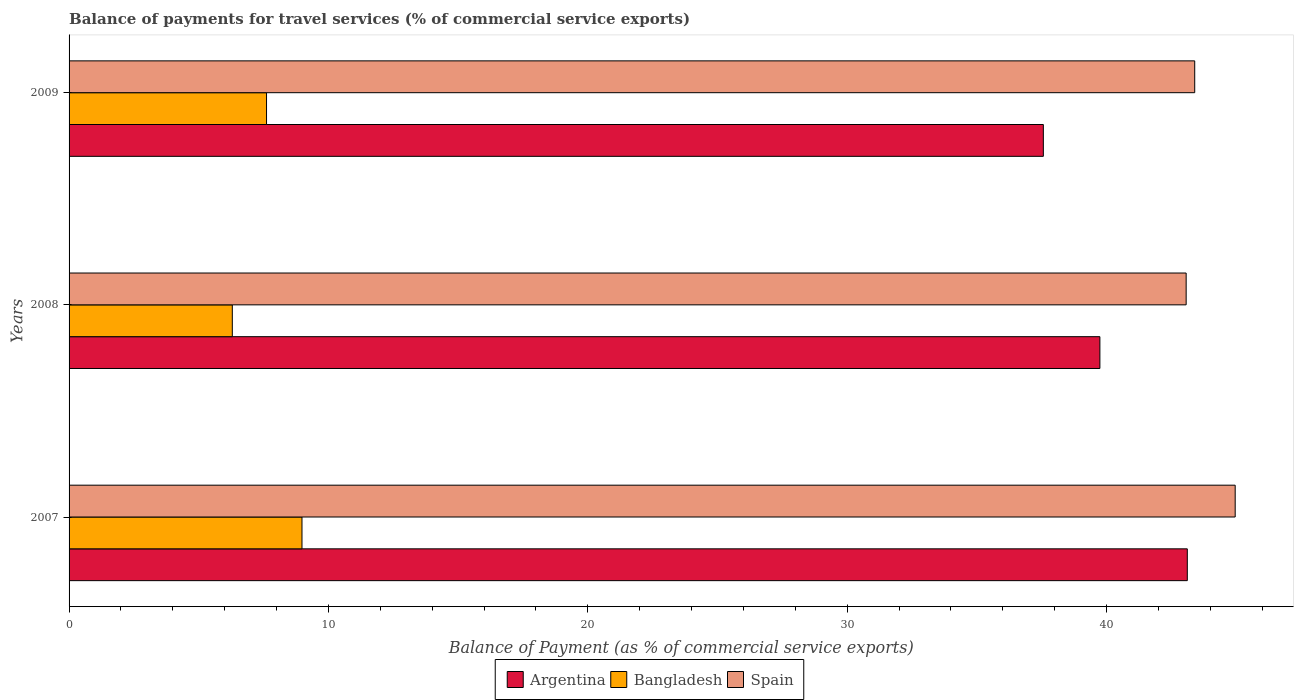How many groups of bars are there?
Give a very brief answer. 3. Are the number of bars on each tick of the Y-axis equal?
Provide a short and direct response. Yes. How many bars are there on the 1st tick from the bottom?
Offer a terse response. 3. What is the label of the 1st group of bars from the top?
Provide a succinct answer. 2009. In how many cases, is the number of bars for a given year not equal to the number of legend labels?
Provide a short and direct response. 0. What is the balance of payments for travel services in Bangladesh in 2009?
Provide a short and direct response. 7.61. Across all years, what is the maximum balance of payments for travel services in Spain?
Offer a terse response. 44.96. Across all years, what is the minimum balance of payments for travel services in Bangladesh?
Your answer should be very brief. 6.29. In which year was the balance of payments for travel services in Argentina maximum?
Your answer should be compact. 2007. In which year was the balance of payments for travel services in Spain minimum?
Your answer should be compact. 2008. What is the total balance of payments for travel services in Bangladesh in the graph?
Provide a succinct answer. 22.89. What is the difference between the balance of payments for travel services in Spain in 2008 and that in 2009?
Give a very brief answer. -0.33. What is the difference between the balance of payments for travel services in Argentina in 2009 and the balance of payments for travel services in Spain in 2007?
Make the answer very short. -7.4. What is the average balance of payments for travel services in Spain per year?
Offer a very short reply. 43.81. In the year 2008, what is the difference between the balance of payments for travel services in Spain and balance of payments for travel services in Bangladesh?
Keep it short and to the point. 36.77. In how many years, is the balance of payments for travel services in Spain greater than 2 %?
Make the answer very short. 3. What is the ratio of the balance of payments for travel services in Argentina in 2008 to that in 2009?
Provide a succinct answer. 1.06. What is the difference between the highest and the second highest balance of payments for travel services in Spain?
Your answer should be compact. 1.56. What is the difference between the highest and the lowest balance of payments for travel services in Spain?
Your response must be concise. 1.89. Is the sum of the balance of payments for travel services in Bangladesh in 2008 and 2009 greater than the maximum balance of payments for travel services in Argentina across all years?
Provide a succinct answer. No. What does the 3rd bar from the top in 2007 represents?
Ensure brevity in your answer.  Argentina. How many years are there in the graph?
Provide a succinct answer. 3. What is the difference between two consecutive major ticks on the X-axis?
Make the answer very short. 10. Does the graph contain any zero values?
Give a very brief answer. No. How are the legend labels stacked?
Your answer should be compact. Horizontal. What is the title of the graph?
Provide a succinct answer. Balance of payments for travel services (% of commercial service exports). Does "Russian Federation" appear as one of the legend labels in the graph?
Your response must be concise. No. What is the label or title of the X-axis?
Your answer should be very brief. Balance of Payment (as % of commercial service exports). What is the Balance of Payment (as % of commercial service exports) of Argentina in 2007?
Give a very brief answer. 43.11. What is the Balance of Payment (as % of commercial service exports) of Bangladesh in 2007?
Your response must be concise. 8.98. What is the Balance of Payment (as % of commercial service exports) of Spain in 2007?
Provide a succinct answer. 44.96. What is the Balance of Payment (as % of commercial service exports) in Argentina in 2008?
Make the answer very short. 39.74. What is the Balance of Payment (as % of commercial service exports) in Bangladesh in 2008?
Give a very brief answer. 6.29. What is the Balance of Payment (as % of commercial service exports) of Spain in 2008?
Provide a short and direct response. 43.07. What is the Balance of Payment (as % of commercial service exports) in Argentina in 2009?
Ensure brevity in your answer.  37.56. What is the Balance of Payment (as % of commercial service exports) of Bangladesh in 2009?
Give a very brief answer. 7.61. What is the Balance of Payment (as % of commercial service exports) in Spain in 2009?
Provide a short and direct response. 43.4. Across all years, what is the maximum Balance of Payment (as % of commercial service exports) in Argentina?
Give a very brief answer. 43.11. Across all years, what is the maximum Balance of Payment (as % of commercial service exports) in Bangladesh?
Offer a terse response. 8.98. Across all years, what is the maximum Balance of Payment (as % of commercial service exports) of Spain?
Make the answer very short. 44.96. Across all years, what is the minimum Balance of Payment (as % of commercial service exports) of Argentina?
Make the answer very short. 37.56. Across all years, what is the minimum Balance of Payment (as % of commercial service exports) in Bangladesh?
Give a very brief answer. 6.29. Across all years, what is the minimum Balance of Payment (as % of commercial service exports) of Spain?
Provide a short and direct response. 43.07. What is the total Balance of Payment (as % of commercial service exports) in Argentina in the graph?
Keep it short and to the point. 120.42. What is the total Balance of Payment (as % of commercial service exports) of Bangladesh in the graph?
Your answer should be very brief. 22.89. What is the total Balance of Payment (as % of commercial service exports) of Spain in the graph?
Offer a very short reply. 131.42. What is the difference between the Balance of Payment (as % of commercial service exports) of Argentina in 2007 and that in 2008?
Provide a short and direct response. 3.37. What is the difference between the Balance of Payment (as % of commercial service exports) in Bangladesh in 2007 and that in 2008?
Ensure brevity in your answer.  2.69. What is the difference between the Balance of Payment (as % of commercial service exports) in Spain in 2007 and that in 2008?
Your answer should be very brief. 1.89. What is the difference between the Balance of Payment (as % of commercial service exports) in Argentina in 2007 and that in 2009?
Offer a terse response. 5.55. What is the difference between the Balance of Payment (as % of commercial service exports) of Bangladesh in 2007 and that in 2009?
Offer a terse response. 1.37. What is the difference between the Balance of Payment (as % of commercial service exports) of Spain in 2007 and that in 2009?
Give a very brief answer. 1.56. What is the difference between the Balance of Payment (as % of commercial service exports) in Argentina in 2008 and that in 2009?
Give a very brief answer. 2.18. What is the difference between the Balance of Payment (as % of commercial service exports) of Bangladesh in 2008 and that in 2009?
Offer a terse response. -1.32. What is the difference between the Balance of Payment (as % of commercial service exports) of Spain in 2008 and that in 2009?
Give a very brief answer. -0.33. What is the difference between the Balance of Payment (as % of commercial service exports) of Argentina in 2007 and the Balance of Payment (as % of commercial service exports) of Bangladesh in 2008?
Give a very brief answer. 36.82. What is the difference between the Balance of Payment (as % of commercial service exports) of Argentina in 2007 and the Balance of Payment (as % of commercial service exports) of Spain in 2008?
Your answer should be compact. 0.04. What is the difference between the Balance of Payment (as % of commercial service exports) in Bangladesh in 2007 and the Balance of Payment (as % of commercial service exports) in Spain in 2008?
Ensure brevity in your answer.  -34.09. What is the difference between the Balance of Payment (as % of commercial service exports) of Argentina in 2007 and the Balance of Payment (as % of commercial service exports) of Bangladesh in 2009?
Ensure brevity in your answer.  35.5. What is the difference between the Balance of Payment (as % of commercial service exports) in Argentina in 2007 and the Balance of Payment (as % of commercial service exports) in Spain in 2009?
Provide a short and direct response. -0.29. What is the difference between the Balance of Payment (as % of commercial service exports) in Bangladesh in 2007 and the Balance of Payment (as % of commercial service exports) in Spain in 2009?
Your response must be concise. -34.42. What is the difference between the Balance of Payment (as % of commercial service exports) in Argentina in 2008 and the Balance of Payment (as % of commercial service exports) in Bangladesh in 2009?
Offer a very short reply. 32.13. What is the difference between the Balance of Payment (as % of commercial service exports) in Argentina in 2008 and the Balance of Payment (as % of commercial service exports) in Spain in 2009?
Offer a very short reply. -3.66. What is the difference between the Balance of Payment (as % of commercial service exports) in Bangladesh in 2008 and the Balance of Payment (as % of commercial service exports) in Spain in 2009?
Provide a succinct answer. -37.1. What is the average Balance of Payment (as % of commercial service exports) in Argentina per year?
Offer a very short reply. 40.14. What is the average Balance of Payment (as % of commercial service exports) in Bangladesh per year?
Your answer should be compact. 7.63. What is the average Balance of Payment (as % of commercial service exports) in Spain per year?
Provide a succinct answer. 43.81. In the year 2007, what is the difference between the Balance of Payment (as % of commercial service exports) of Argentina and Balance of Payment (as % of commercial service exports) of Bangladesh?
Give a very brief answer. 34.13. In the year 2007, what is the difference between the Balance of Payment (as % of commercial service exports) in Argentina and Balance of Payment (as % of commercial service exports) in Spain?
Provide a succinct answer. -1.85. In the year 2007, what is the difference between the Balance of Payment (as % of commercial service exports) of Bangladesh and Balance of Payment (as % of commercial service exports) of Spain?
Provide a short and direct response. -35.98. In the year 2008, what is the difference between the Balance of Payment (as % of commercial service exports) of Argentina and Balance of Payment (as % of commercial service exports) of Bangladesh?
Offer a very short reply. 33.45. In the year 2008, what is the difference between the Balance of Payment (as % of commercial service exports) in Argentina and Balance of Payment (as % of commercial service exports) in Spain?
Offer a very short reply. -3.33. In the year 2008, what is the difference between the Balance of Payment (as % of commercial service exports) of Bangladesh and Balance of Payment (as % of commercial service exports) of Spain?
Your answer should be compact. -36.77. In the year 2009, what is the difference between the Balance of Payment (as % of commercial service exports) in Argentina and Balance of Payment (as % of commercial service exports) in Bangladesh?
Your answer should be compact. 29.95. In the year 2009, what is the difference between the Balance of Payment (as % of commercial service exports) in Argentina and Balance of Payment (as % of commercial service exports) in Spain?
Make the answer very short. -5.84. In the year 2009, what is the difference between the Balance of Payment (as % of commercial service exports) of Bangladesh and Balance of Payment (as % of commercial service exports) of Spain?
Provide a succinct answer. -35.78. What is the ratio of the Balance of Payment (as % of commercial service exports) of Argentina in 2007 to that in 2008?
Make the answer very short. 1.08. What is the ratio of the Balance of Payment (as % of commercial service exports) in Bangladesh in 2007 to that in 2008?
Your answer should be compact. 1.43. What is the ratio of the Balance of Payment (as % of commercial service exports) in Spain in 2007 to that in 2008?
Give a very brief answer. 1.04. What is the ratio of the Balance of Payment (as % of commercial service exports) in Argentina in 2007 to that in 2009?
Provide a short and direct response. 1.15. What is the ratio of the Balance of Payment (as % of commercial service exports) of Bangladesh in 2007 to that in 2009?
Provide a short and direct response. 1.18. What is the ratio of the Balance of Payment (as % of commercial service exports) of Spain in 2007 to that in 2009?
Keep it short and to the point. 1.04. What is the ratio of the Balance of Payment (as % of commercial service exports) in Argentina in 2008 to that in 2009?
Offer a very short reply. 1.06. What is the ratio of the Balance of Payment (as % of commercial service exports) of Bangladesh in 2008 to that in 2009?
Ensure brevity in your answer.  0.83. What is the difference between the highest and the second highest Balance of Payment (as % of commercial service exports) in Argentina?
Your answer should be compact. 3.37. What is the difference between the highest and the second highest Balance of Payment (as % of commercial service exports) in Bangladesh?
Provide a succinct answer. 1.37. What is the difference between the highest and the second highest Balance of Payment (as % of commercial service exports) of Spain?
Your response must be concise. 1.56. What is the difference between the highest and the lowest Balance of Payment (as % of commercial service exports) of Argentina?
Provide a succinct answer. 5.55. What is the difference between the highest and the lowest Balance of Payment (as % of commercial service exports) in Bangladesh?
Your response must be concise. 2.69. What is the difference between the highest and the lowest Balance of Payment (as % of commercial service exports) in Spain?
Your response must be concise. 1.89. 